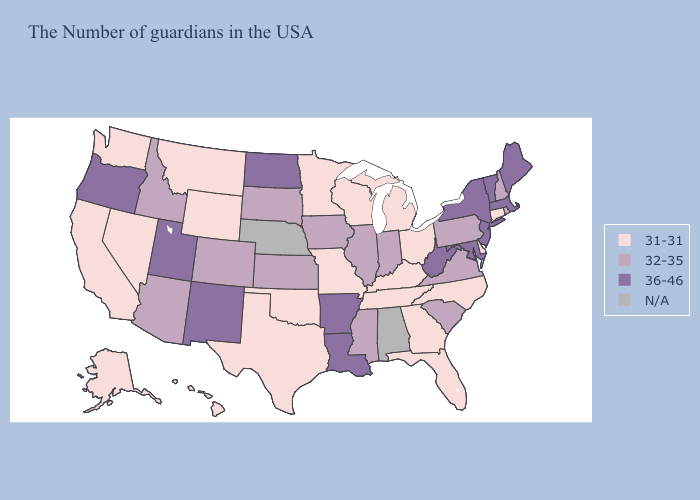What is the lowest value in states that border North Dakota?
Answer briefly. 31-31. Does New Jersey have the highest value in the USA?
Keep it brief. Yes. Does Kansas have the lowest value in the MidWest?
Write a very short answer. No. What is the value of Maine?
Be succinct. 36-46. What is the value of South Dakota?
Write a very short answer. 32-35. Name the states that have a value in the range 32-35?
Be succinct. Rhode Island, New Hampshire, Pennsylvania, Virginia, South Carolina, Indiana, Illinois, Mississippi, Iowa, Kansas, South Dakota, Colorado, Arizona, Idaho. What is the value of Colorado?
Quick response, please. 32-35. Among the states that border West Virginia , which have the highest value?
Answer briefly. Maryland. What is the value of Arkansas?
Give a very brief answer. 36-46. Which states have the lowest value in the USA?
Answer briefly. Connecticut, Delaware, North Carolina, Ohio, Florida, Georgia, Michigan, Kentucky, Tennessee, Wisconsin, Missouri, Minnesota, Oklahoma, Texas, Wyoming, Montana, Nevada, California, Washington, Alaska, Hawaii. Is the legend a continuous bar?
Answer briefly. No. Name the states that have a value in the range 32-35?
Be succinct. Rhode Island, New Hampshire, Pennsylvania, Virginia, South Carolina, Indiana, Illinois, Mississippi, Iowa, Kansas, South Dakota, Colorado, Arizona, Idaho. Name the states that have a value in the range 31-31?
Write a very short answer. Connecticut, Delaware, North Carolina, Ohio, Florida, Georgia, Michigan, Kentucky, Tennessee, Wisconsin, Missouri, Minnesota, Oklahoma, Texas, Wyoming, Montana, Nevada, California, Washington, Alaska, Hawaii. 